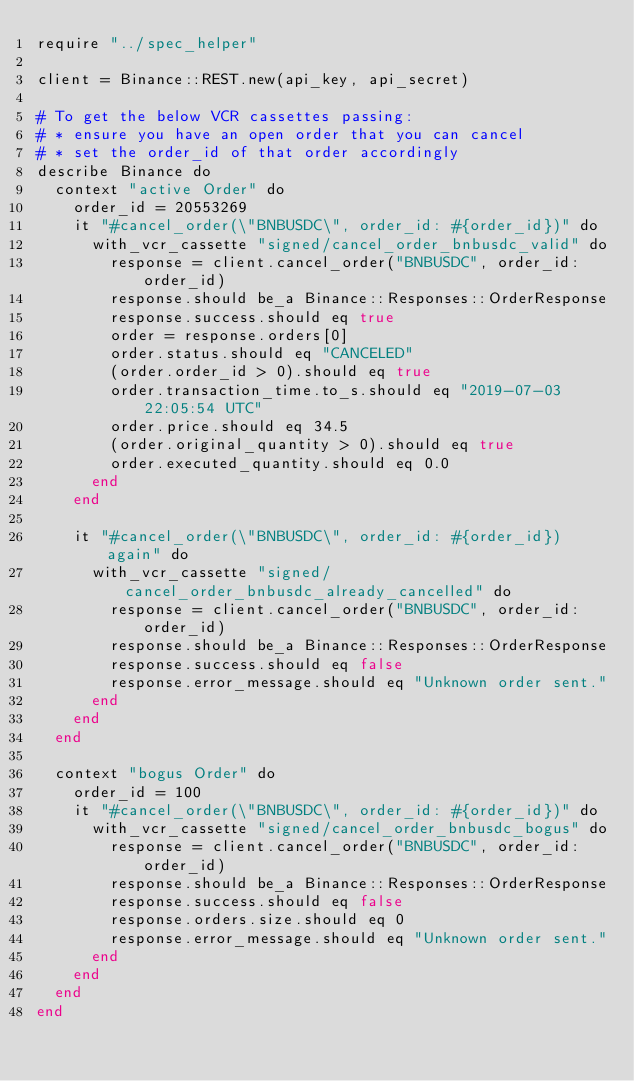Convert code to text. <code><loc_0><loc_0><loc_500><loc_500><_Crystal_>require "../spec_helper"

client = Binance::REST.new(api_key, api_secret)

# To get the below VCR cassettes passing:
# * ensure you have an open order that you can cancel
# * set the order_id of that order accordingly
describe Binance do
  context "active Order" do
    order_id = 20553269
    it "#cancel_order(\"BNBUSDC\", order_id: #{order_id})" do
      with_vcr_cassette "signed/cancel_order_bnbusdc_valid" do
        response = client.cancel_order("BNBUSDC", order_id: order_id)
        response.should be_a Binance::Responses::OrderResponse
        response.success.should eq true
        order = response.orders[0]
        order.status.should eq "CANCELED"
        (order.order_id > 0).should eq true
        order.transaction_time.to_s.should eq "2019-07-03 22:05:54 UTC"
        order.price.should eq 34.5
        (order.original_quantity > 0).should eq true
        order.executed_quantity.should eq 0.0
      end
    end

    it "#cancel_order(\"BNBUSDC\", order_id: #{order_id}) again" do
      with_vcr_cassette "signed/cancel_order_bnbusdc_already_cancelled" do
        response = client.cancel_order("BNBUSDC", order_id: order_id)
        response.should be_a Binance::Responses::OrderResponse
        response.success.should eq false
        response.error_message.should eq "Unknown order sent."
      end
    end
  end

  context "bogus Order" do
    order_id = 100
    it "#cancel_order(\"BNBUSDC\", order_id: #{order_id})" do
      with_vcr_cassette "signed/cancel_order_bnbusdc_bogus" do
        response = client.cancel_order("BNBUSDC", order_id: order_id)
        response.should be_a Binance::Responses::OrderResponse
        response.success.should eq false
        response.orders.size.should eq 0
        response.error_message.should eq "Unknown order sent."
      end
    end
  end
end
</code> 